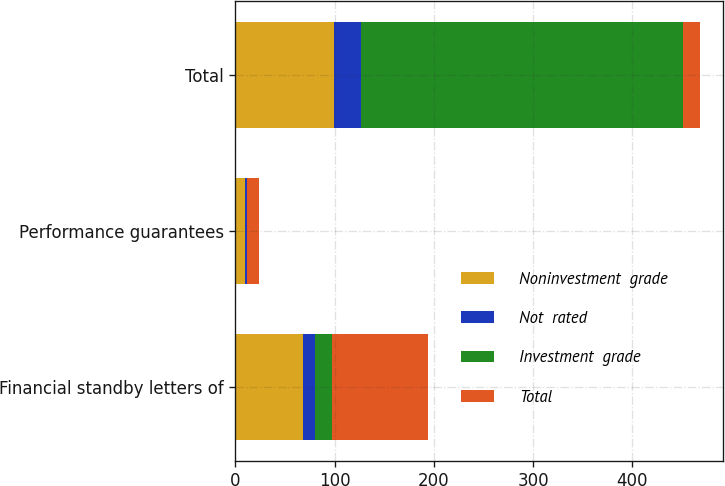Convert chart to OTSL. <chart><loc_0><loc_0><loc_500><loc_500><stacked_bar_chart><ecel><fcel>Financial standby letters of<fcel>Performance guarantees<fcel>Total<nl><fcel>Noninvestment  grade<fcel>68.3<fcel>9.2<fcel>99.7<nl><fcel>Not  rated<fcel>11.8<fcel>2.1<fcel>27.1<nl><fcel>Investment  grade<fcel>17<fcel>0.6<fcel>324.1<nl><fcel>Total<fcel>97.1<fcel>11.9<fcel>17<nl></chart> 